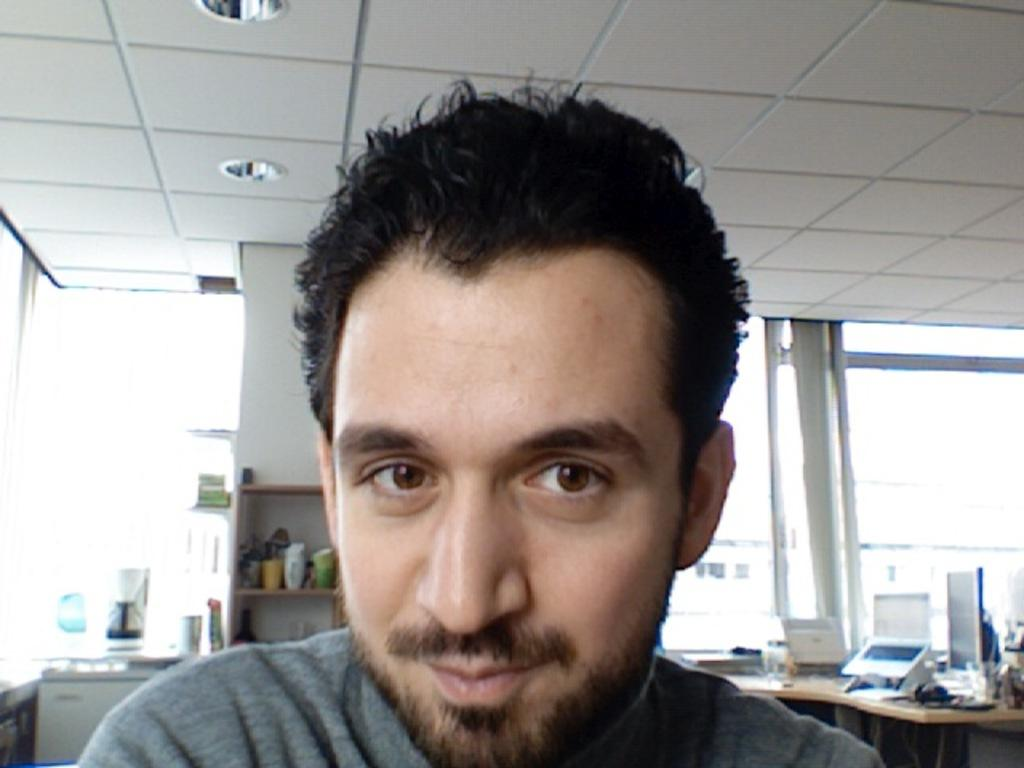What is the main subject of the image? There is a person in the image. Can you describe the person's appearance? The person has a short beard. What else can be seen in the image besides the person? There are other objects visible behind the person. What type of apparel is the person's mom wearing in the image? There is no mention of the person's mom or any apparel in the image, so we cannot answer this question. 